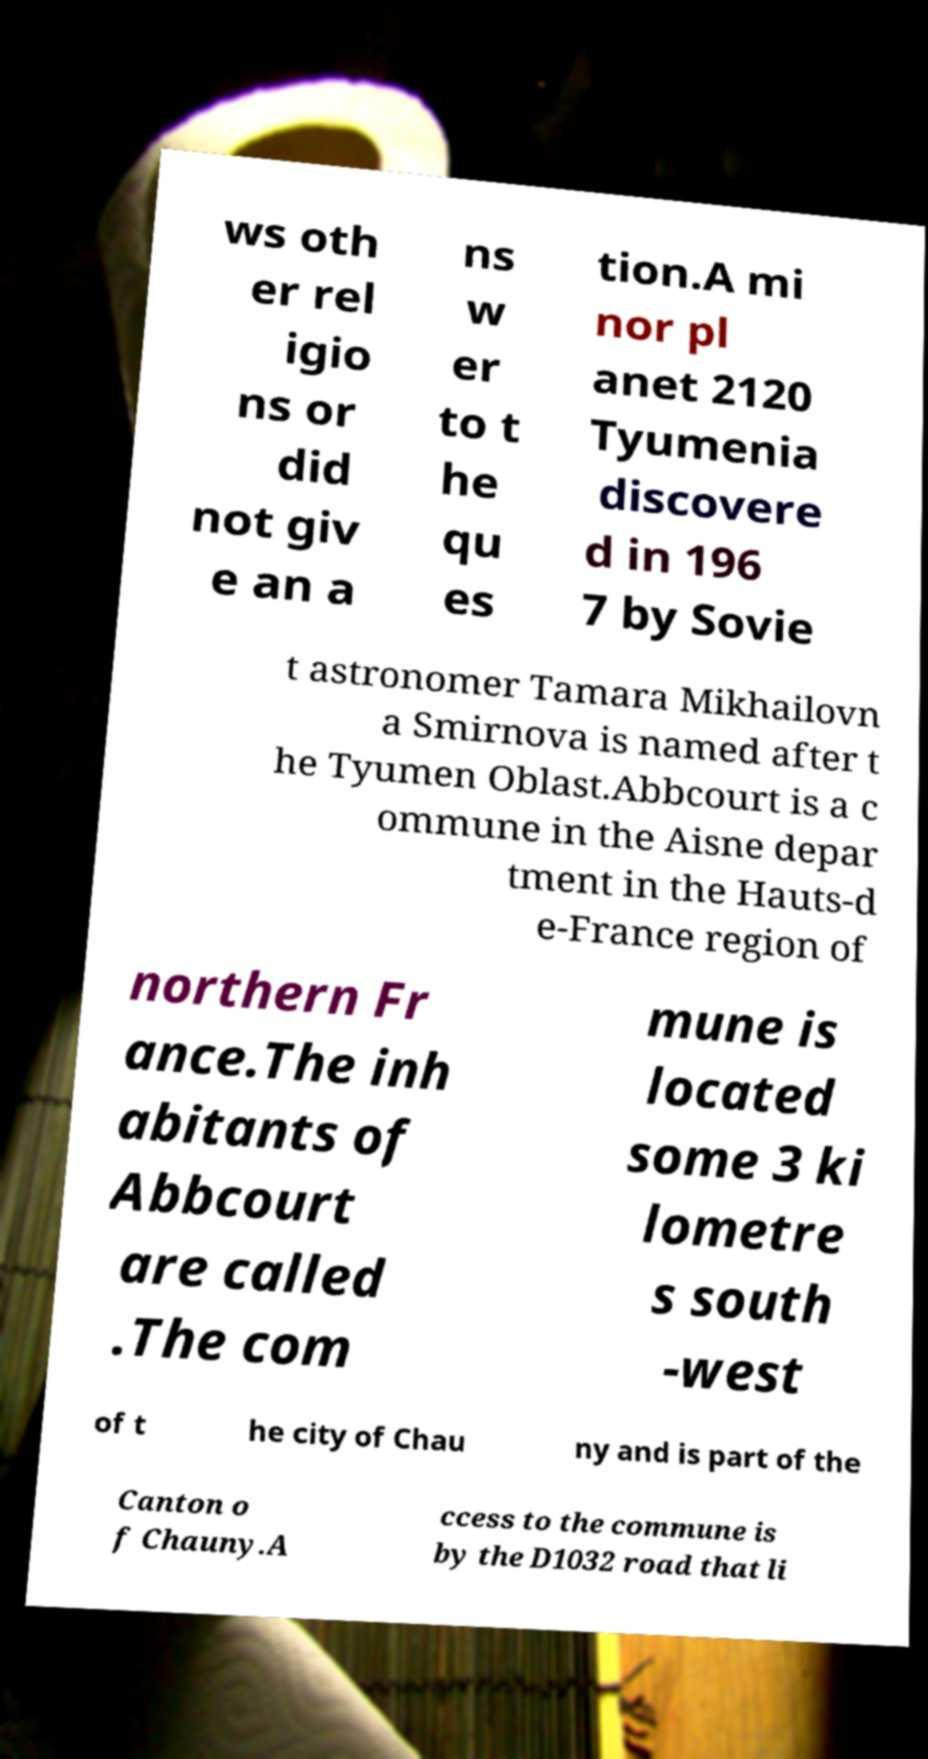What messages or text are displayed in this image? I need them in a readable, typed format. ws oth er rel igio ns or did not giv e an a ns w er to t he qu es tion.A mi nor pl anet 2120 Tyumenia discovere d in 196 7 by Sovie t astronomer Tamara Mikhailovn a Smirnova is named after t he Tyumen Oblast.Abbcourt is a c ommune in the Aisne depar tment in the Hauts-d e-France region of northern Fr ance.The inh abitants of Abbcourt are called .The com mune is located some 3 ki lometre s south -west of t he city of Chau ny and is part of the Canton o f Chauny.A ccess to the commune is by the D1032 road that li 